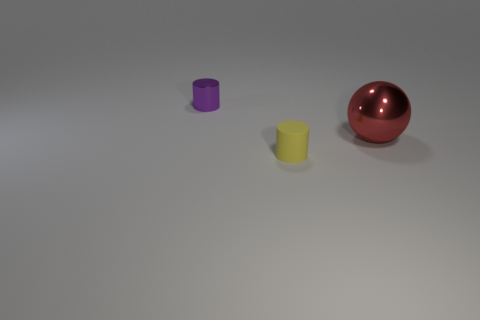Add 2 large red metal spheres. How many objects exist? 5 Subtract all yellow cylinders. How many cylinders are left? 1 Subtract all spheres. How many objects are left? 2 Subtract 1 cylinders. How many cylinders are left? 1 Subtract 0 cyan blocks. How many objects are left? 3 Subtract all blue spheres. Subtract all red cubes. How many spheres are left? 1 Subtract all blue objects. Subtract all large balls. How many objects are left? 2 Add 2 tiny yellow things. How many tiny yellow things are left? 3 Add 2 small brown matte cubes. How many small brown matte cubes exist? 2 